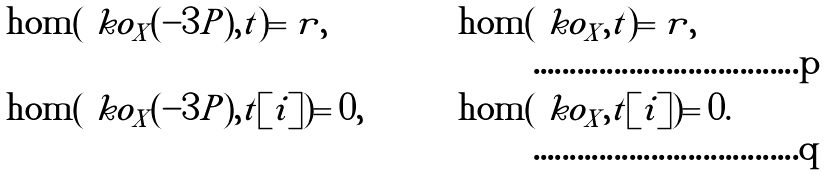<formula> <loc_0><loc_0><loc_500><loc_500>& \hom ( \ k o _ { X } ( - 3 P ) , t ) = r , & & \hom ( \ k o _ { X } , t ) = r , \\ & \hom ( \ k o _ { X } ( - 3 P ) , t [ i ] ) = 0 , & & \hom ( \ k o _ { X } , t [ i ] ) = 0 .</formula> 